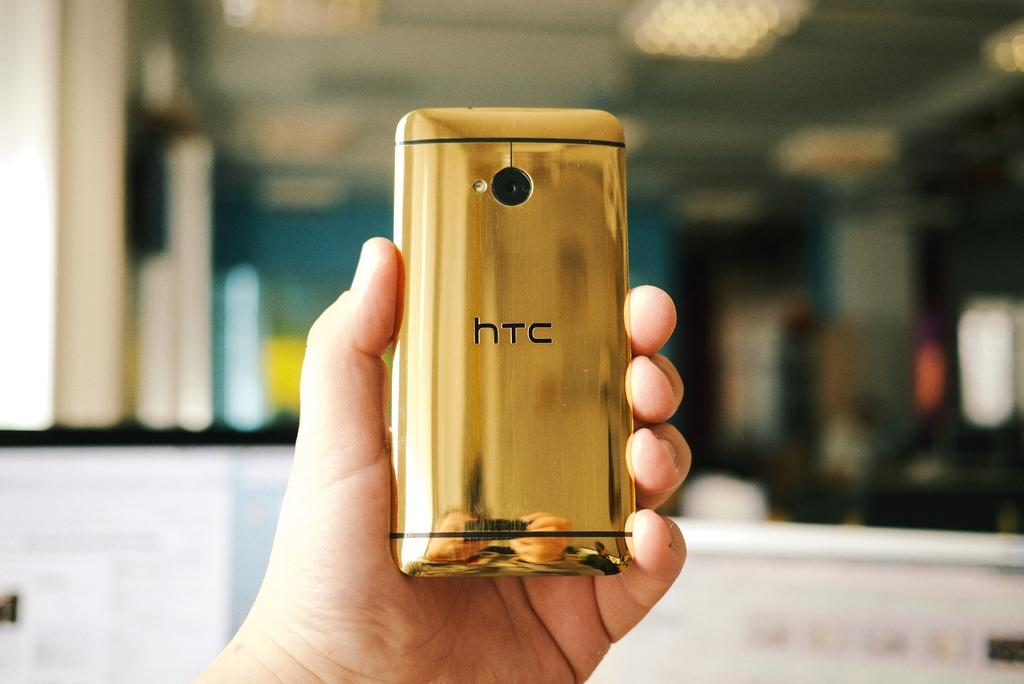<image>
Summarize the visual content of the image. A hand is holding a gold htc phone, displaying the back. 